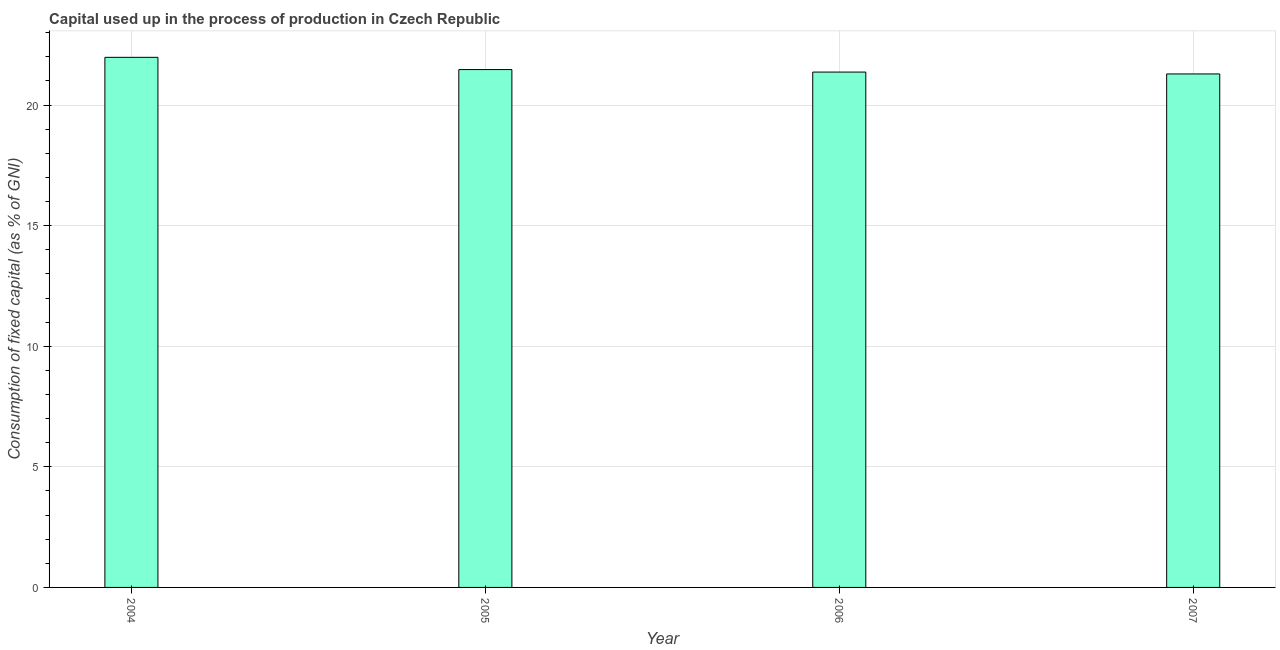Does the graph contain grids?
Your answer should be very brief. Yes. What is the title of the graph?
Offer a terse response. Capital used up in the process of production in Czech Republic. What is the label or title of the Y-axis?
Give a very brief answer. Consumption of fixed capital (as % of GNI). What is the consumption of fixed capital in 2004?
Your answer should be compact. 21.98. Across all years, what is the maximum consumption of fixed capital?
Provide a short and direct response. 21.98. Across all years, what is the minimum consumption of fixed capital?
Provide a short and direct response. 21.29. In which year was the consumption of fixed capital maximum?
Ensure brevity in your answer.  2004. What is the sum of the consumption of fixed capital?
Offer a terse response. 86.11. What is the difference between the consumption of fixed capital in 2004 and 2006?
Offer a very short reply. 0.61. What is the average consumption of fixed capital per year?
Your response must be concise. 21.53. What is the median consumption of fixed capital?
Ensure brevity in your answer.  21.42. Do a majority of the years between 2006 and 2007 (inclusive) have consumption of fixed capital greater than 10 %?
Provide a succinct answer. Yes. What is the ratio of the consumption of fixed capital in 2004 to that in 2006?
Give a very brief answer. 1.03. Is the consumption of fixed capital in 2004 less than that in 2005?
Provide a short and direct response. No. Is the difference between the consumption of fixed capital in 2004 and 2005 greater than the difference between any two years?
Provide a succinct answer. No. What is the difference between the highest and the second highest consumption of fixed capital?
Make the answer very short. 0.51. Is the sum of the consumption of fixed capital in 2005 and 2006 greater than the maximum consumption of fixed capital across all years?
Offer a very short reply. Yes. What is the difference between the highest and the lowest consumption of fixed capital?
Offer a very short reply. 0.69. Are all the bars in the graph horizontal?
Ensure brevity in your answer.  No. Are the values on the major ticks of Y-axis written in scientific E-notation?
Your answer should be compact. No. What is the Consumption of fixed capital (as % of GNI) of 2004?
Your answer should be very brief. 21.98. What is the Consumption of fixed capital (as % of GNI) of 2005?
Your response must be concise. 21.47. What is the Consumption of fixed capital (as % of GNI) in 2006?
Your response must be concise. 21.37. What is the Consumption of fixed capital (as % of GNI) in 2007?
Your answer should be compact. 21.29. What is the difference between the Consumption of fixed capital (as % of GNI) in 2004 and 2005?
Offer a terse response. 0.51. What is the difference between the Consumption of fixed capital (as % of GNI) in 2004 and 2006?
Give a very brief answer. 0.61. What is the difference between the Consumption of fixed capital (as % of GNI) in 2004 and 2007?
Your response must be concise. 0.69. What is the difference between the Consumption of fixed capital (as % of GNI) in 2005 and 2006?
Ensure brevity in your answer.  0.1. What is the difference between the Consumption of fixed capital (as % of GNI) in 2005 and 2007?
Offer a very short reply. 0.18. What is the difference between the Consumption of fixed capital (as % of GNI) in 2006 and 2007?
Provide a succinct answer. 0.08. What is the ratio of the Consumption of fixed capital (as % of GNI) in 2004 to that in 2005?
Your response must be concise. 1.02. What is the ratio of the Consumption of fixed capital (as % of GNI) in 2004 to that in 2007?
Your response must be concise. 1.03. 